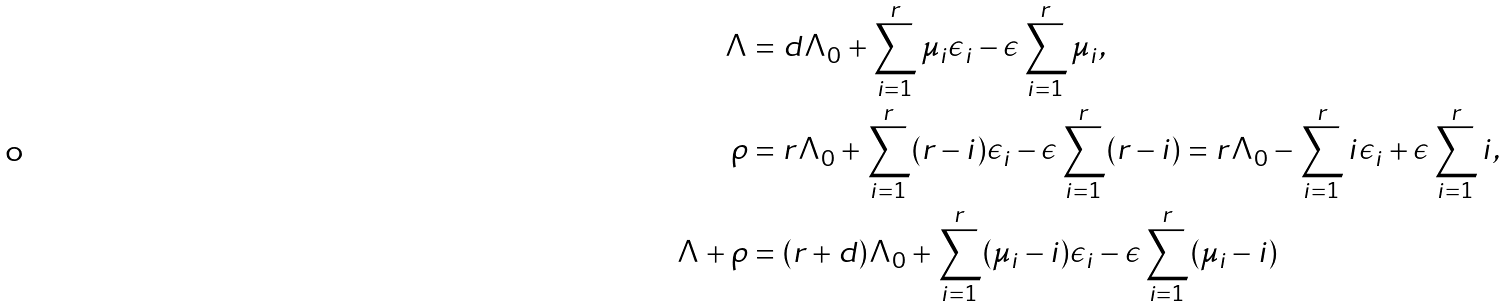<formula> <loc_0><loc_0><loc_500><loc_500>\Lambda & = d \Lambda _ { 0 } + \sum _ { i = 1 } ^ { r } \mu _ { i } \epsilon _ { i } - \epsilon \sum _ { i = 1 } ^ { r } \mu _ { i } , \\ \rho & = r \Lambda _ { 0 } + \sum _ { i = 1 } ^ { r } ( r - i ) \epsilon _ { i } - \epsilon \sum _ { i = 1 } ^ { r } ( r - i ) = r \Lambda _ { 0 } - \sum _ { i = 1 } ^ { r } i \epsilon _ { i } + \epsilon \sum _ { i = 1 } ^ { r } i , \\ \Lambda + \rho & = ( r + d ) \Lambda _ { 0 } + \sum _ { i = 1 } ^ { r } ( \mu _ { i } - i ) \epsilon _ { i } - \epsilon \sum _ { i = 1 } ^ { r } ( \mu _ { i } - i )</formula> 